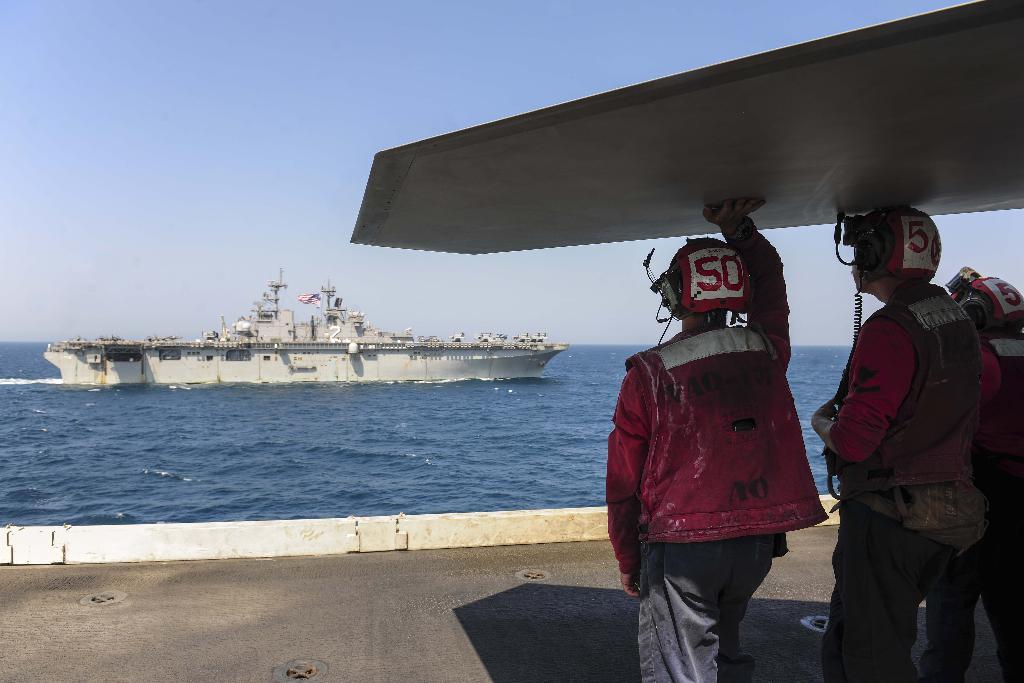What number is on the man's helmet?
Offer a terse response. 50. 